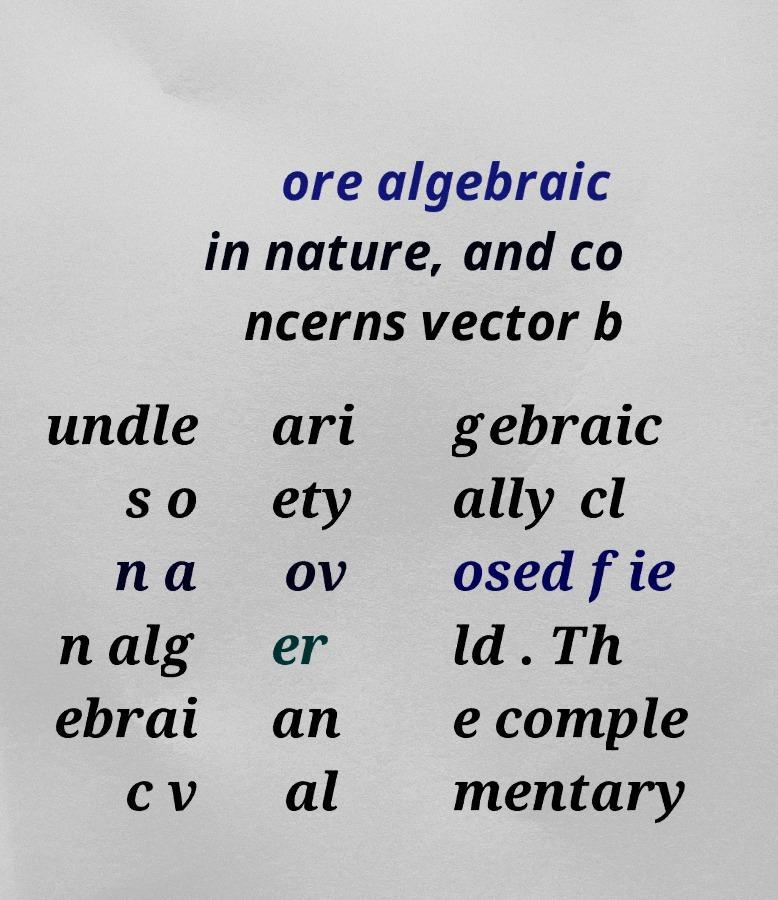I need the written content from this picture converted into text. Can you do that? ore algebraic in nature, and co ncerns vector b undle s o n a n alg ebrai c v ari ety ov er an al gebraic ally cl osed fie ld . Th e comple mentary 